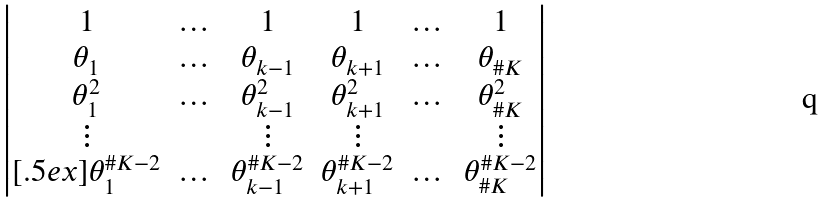<formula> <loc_0><loc_0><loc_500><loc_500>\begin{vmatrix} 1 & \dots & 1 & 1 & \dots & 1 \\ \theta _ { 1 } & \dots & \theta _ { k - 1 } & \theta _ { k + 1 } & \dots & \theta _ { \# K } \\ \theta _ { 1 } ^ { 2 } & \dots & \theta _ { k - 1 } ^ { 2 } & \theta _ { k + 1 } ^ { 2 } & \dots & \theta _ { \# K } ^ { 2 } \\ \vdots & & \vdots & \vdots & & \vdots \\ [ . 5 e x ] \theta _ { 1 } ^ { \# K - 2 } & \dots & \theta _ { k - 1 } ^ { \# K - 2 } & \theta _ { k + 1 } ^ { \# K - 2 } & \dots & \theta _ { \# K } ^ { \# K - 2 } \end{vmatrix}</formula> 